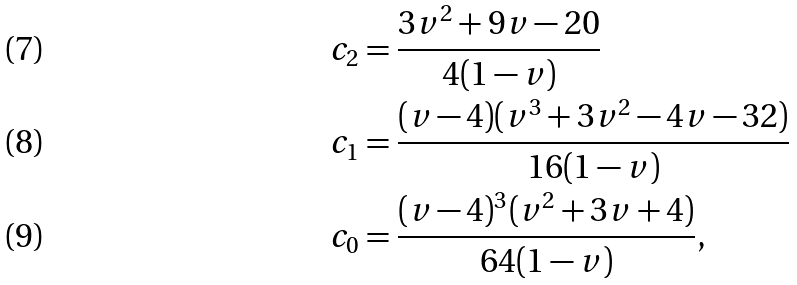Convert formula to latex. <formula><loc_0><loc_0><loc_500><loc_500>c _ { 2 } & = \frac { 3 v ^ { 2 } + 9 v - 2 0 } { 4 ( 1 - v ) } \\ c _ { 1 } & = \frac { ( v - 4 ) ( v ^ { 3 } + 3 v ^ { 2 } - 4 v - 3 2 ) } { 1 6 ( 1 - v ) } \\ c _ { 0 } & = \frac { ( v - 4 ) ^ { 3 } ( v ^ { 2 } + 3 v + 4 ) } { 6 4 ( 1 - v ) } ,</formula> 